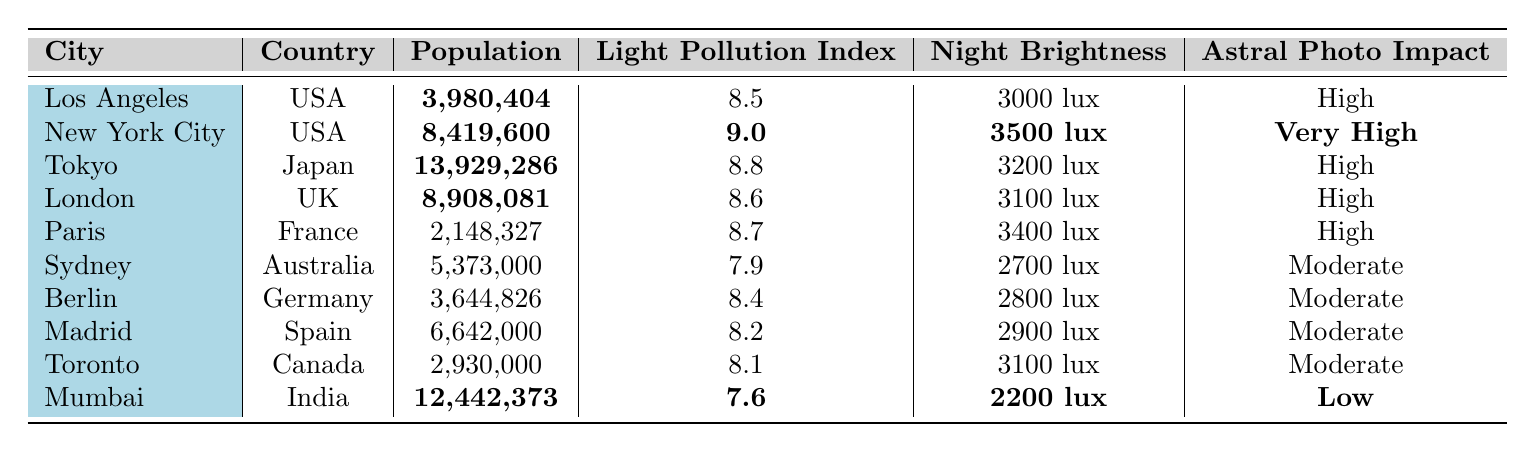What is the light pollution index of New York City? The table shows the light pollution index for New York City, which is directly listed as 9.0.
Answer: 9.0 Which city has the highest population? By comparing the population figures listed in the table, New York City's population is the highest at 8,419,600.
Answer: New York City How many cities have a light pollution index of 8.6 or higher? The cities with a light pollution index of 8.6 or higher are New York City (9.0), Tokyo (8.8), Paris (8.7), and London (8.6), giving us a total of four cities.
Answer: 4 Which city has the lowest average night brightness? The average night brightness for each city is listed, with Mumbai having the lowest value at 2200 lux.
Answer: Mumbai What is the average population of the cities listed in the table? To find the average, sum the populations: 3,980,404 + 8,419,600 + 13,929,286 + 8,908,081 + 2,148,327 + 5,373,000 + 3,644,826 + 6,642,000 + 2,930,000 + 12,442,373 = 64,536,897. Then, divide by the number of cities (10): 64,536,897 / 10 = 6,453,689.7.
Answer: 6,453,689.7 Is the light pollution index of Mumbai higher than that of Sydney? The table shows Mumbai's light pollution index as 7.6 and Sydney's as 7.9; therefore, it is false that Mumbai's index is higher.
Answer: No Which cities have a "High" impact on astral photography? The cities identified with a "High" impact on astral photography are Los Angeles, Tokyo, London, and Paris, totaling four cities.
Answer: 4 What is the difference in light pollution index between New York City and Mumbai? New York City's index is 9.0 and Mumbai's is 7.6. The difference is 9.0 - 7.6 = 1.4.
Answer: 1.4 Are there more cities with a "Moderate" impact on astral photography than those with a "High" impact? By counting, there are six cities with a "Moderate" impact (Sydney, Berlin, Madrid, and Toronto) and four cities with a "High" impact. Thus, it is true that there are more moderate cities.
Answer: Yes Which country has the most cities listed in this table? Analyzing the table, the USA has three cities listed: Los Angeles, New York City, and another one, making it the country with the most entries.
Answer: USA What is the average night brightness for cities with a "Very High" impact? The table shows only New York City with a "Very High" impact having an average night brightness of 3500 lux, so the average is simply 3500 lux.
Answer: 3500 lux 